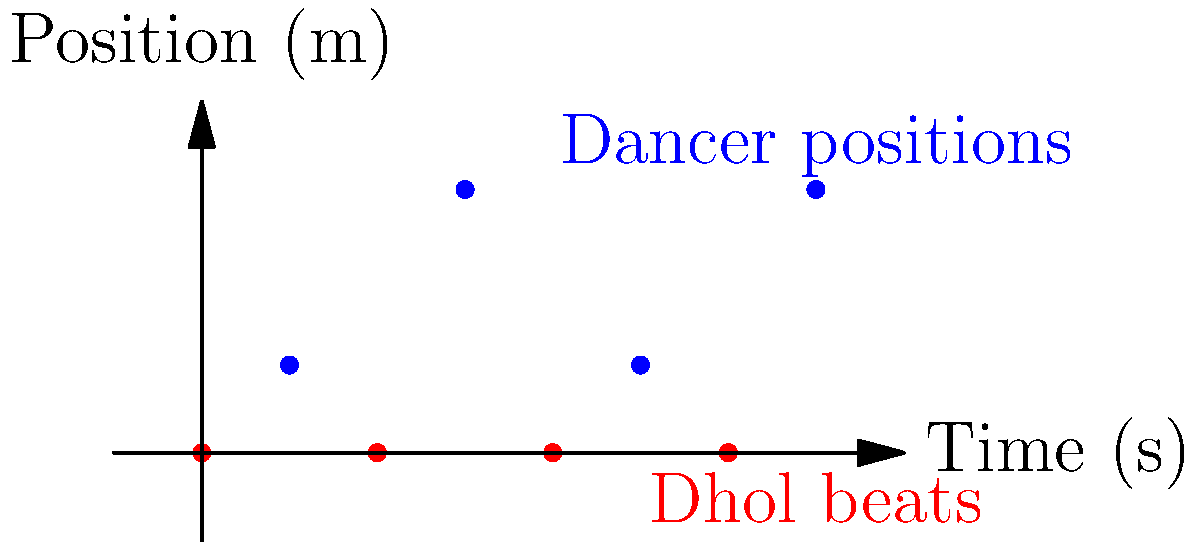In a Bollywood dance performance, the dancer's movements are synchronized with the dhol player's beats. The graph shows the dhol beats (red dots) on the x-axis and the dancer's positions (blue dots) on the coordinate plane. If the dancer's position follows the pattern $(x, y) = (2n-1, 2\sin(\frac{\pi n}{2})+1)$ where $n$ is the beat number, what will be the dancer's position at the 5th beat? To find the dancer's position at the 5th beat, we need to follow these steps:

1. Identify the pattern:
   The dancer's position is given by $(x, y) = (2n-1, 2\sin(\frac{\pi n}{2})+1)$

2. Substitute $n=5$ for the 5th beat:
   $x = 2(5) - 1 = 9$
   $y = 2\sin(\frac{\pi 5}{2}) + 1$

3. Calculate the y-coordinate:
   $y = 2\sin(\frac{5\pi}{2}) + 1$
   $\sin(\frac{5\pi}{2}) = \sin(\frac{\pi}{2}) = 1$
   $y = 2(1) + 1 = 3$

4. Combine the x and y coordinates:
   The dancer's position at the 5th beat will be $(9, 3)$
Answer: $(9, 3)$ 